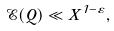<formula> <loc_0><loc_0><loc_500><loc_500>\mathcal { E } ( Q ) \ll X ^ { 1 - \varepsilon } ,</formula> 